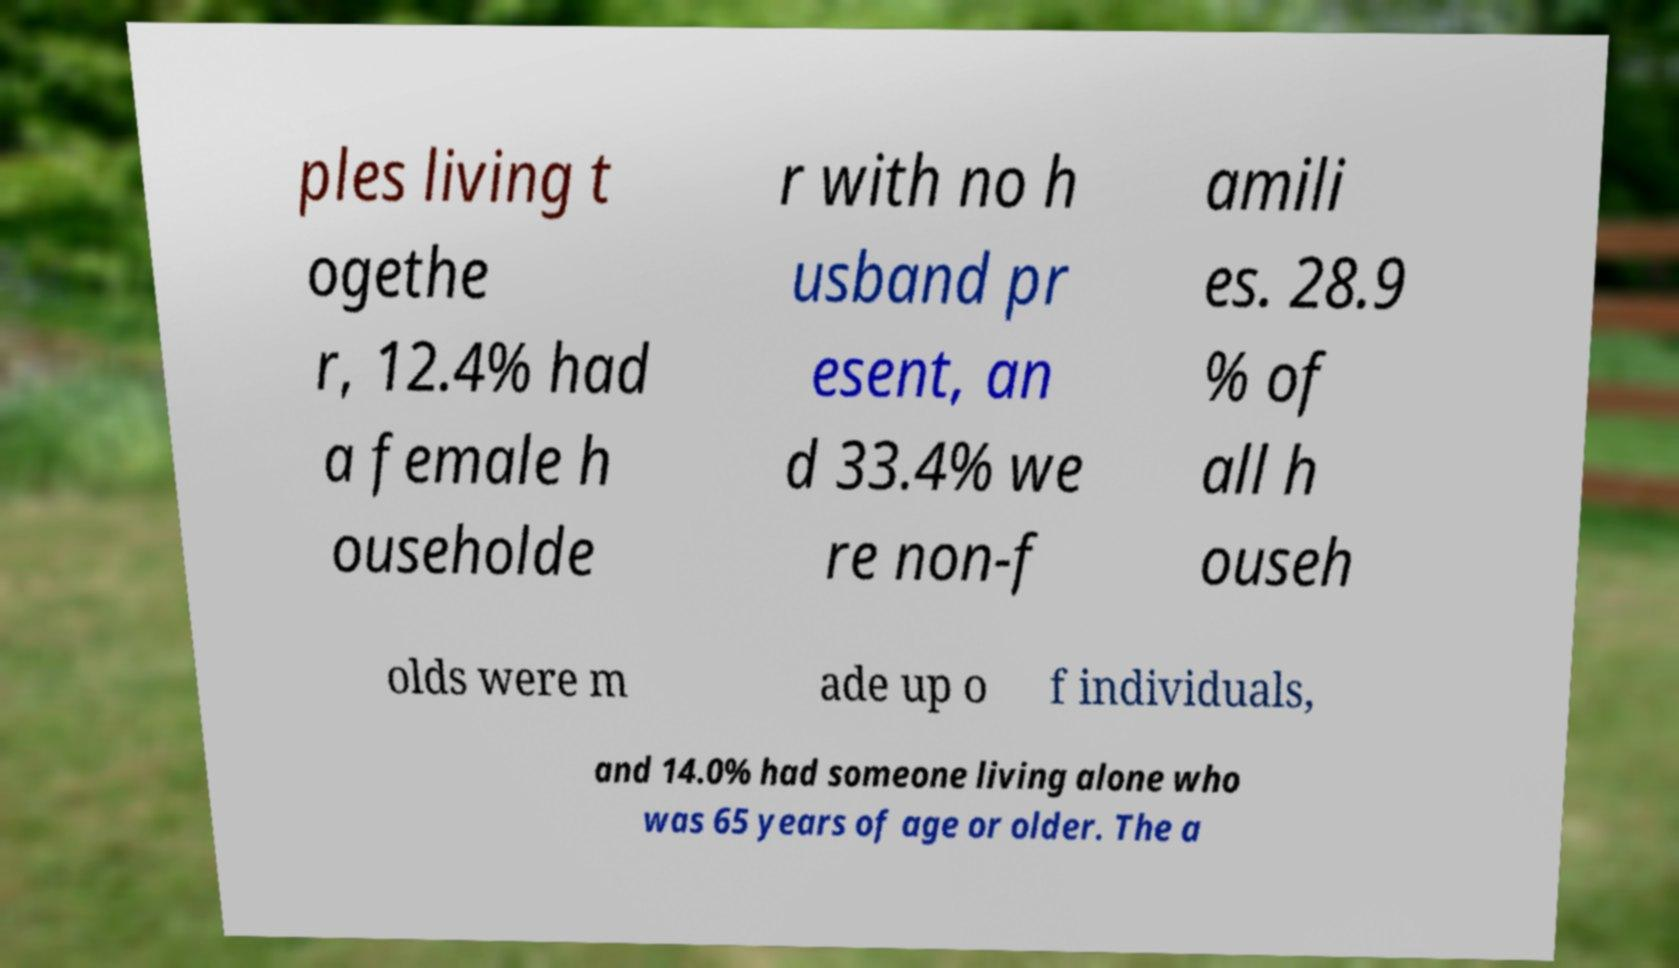Can you accurately transcribe the text from the provided image for me? ples living t ogethe r, 12.4% had a female h ouseholde r with no h usband pr esent, an d 33.4% we re non-f amili es. 28.9 % of all h ouseh olds were m ade up o f individuals, and 14.0% had someone living alone who was 65 years of age or older. The a 